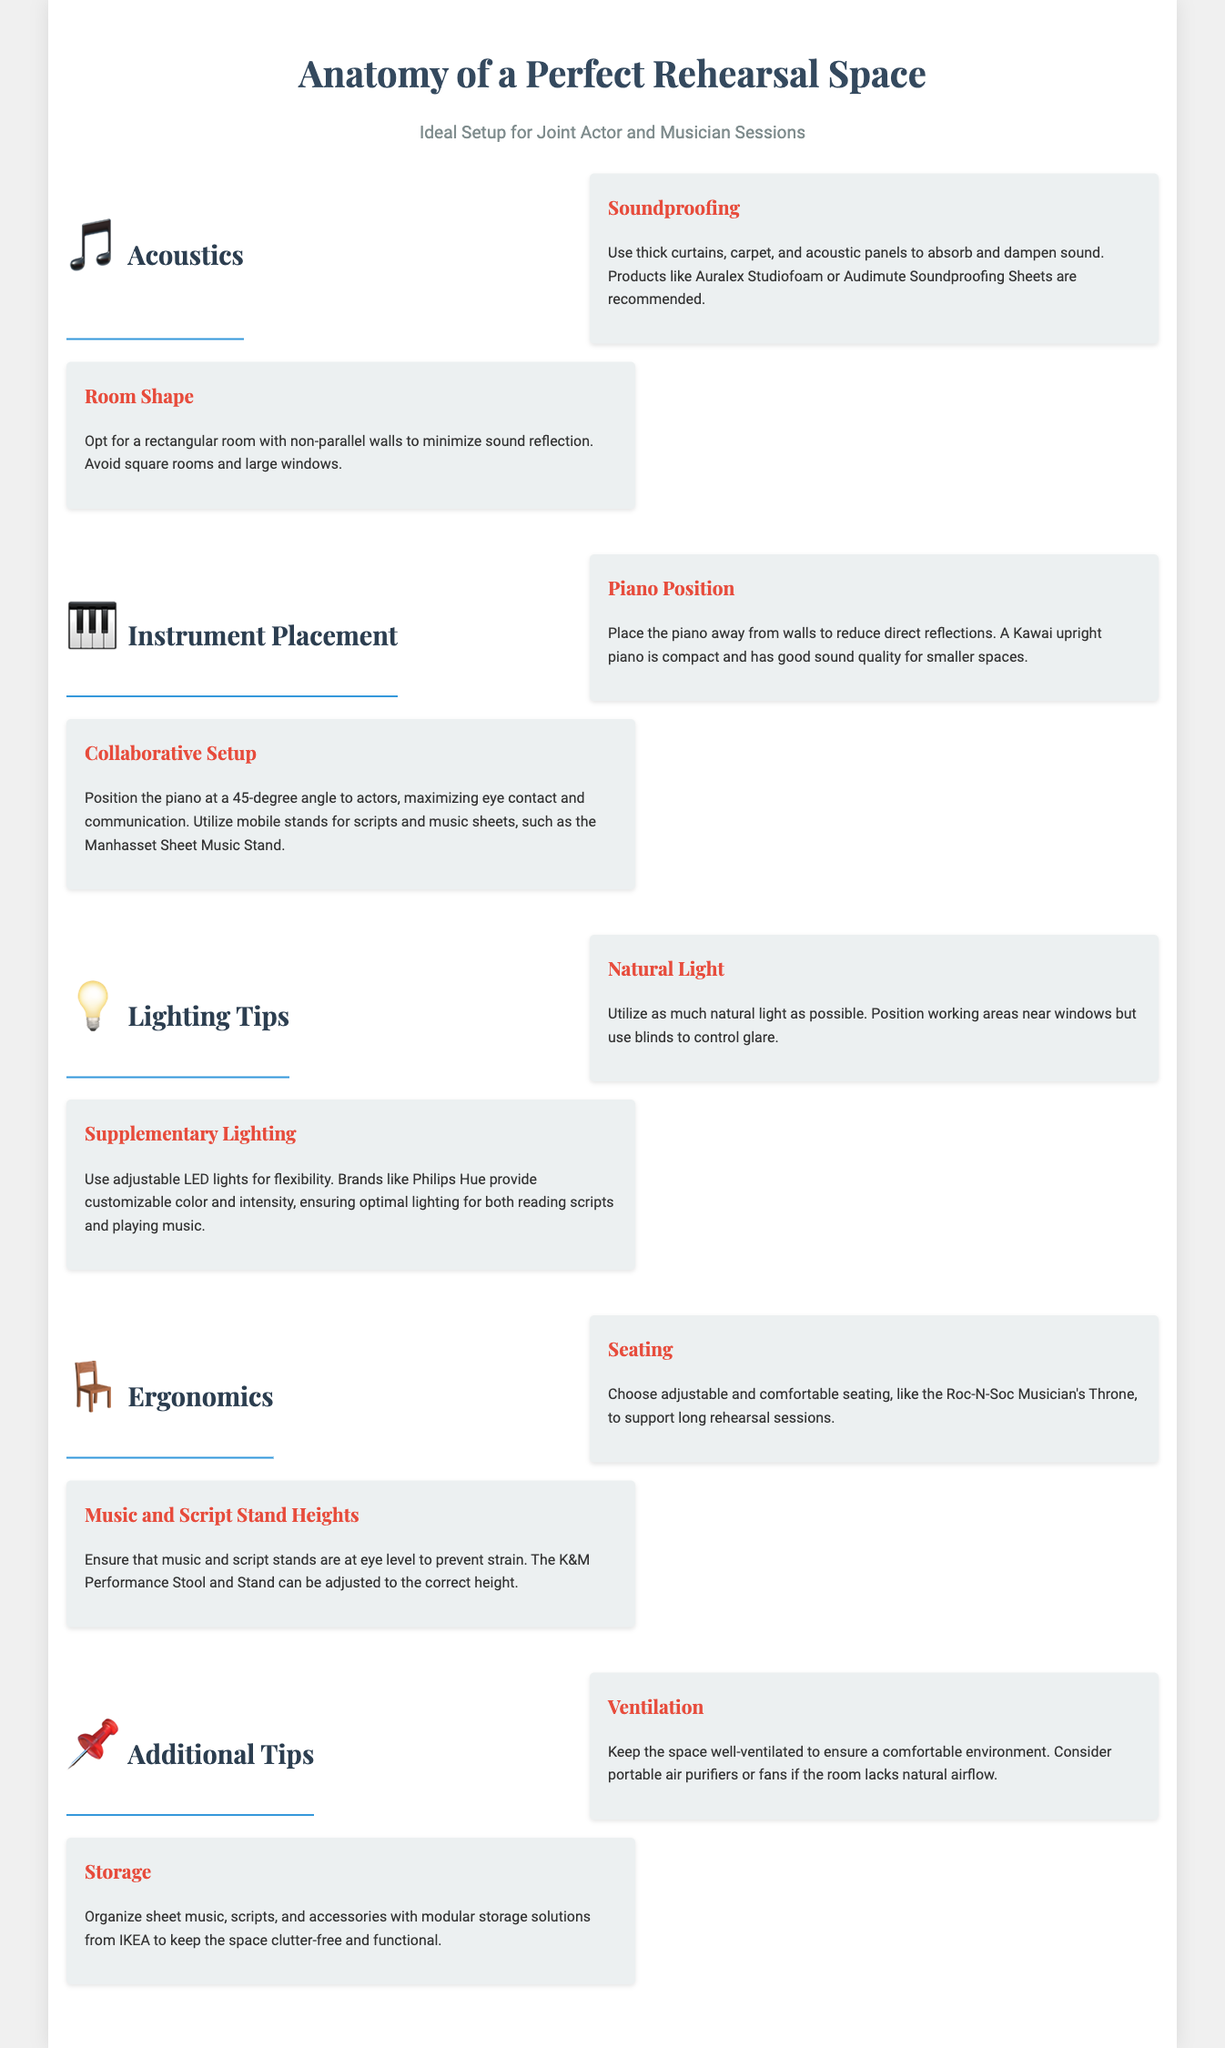what are recommended products for soundproofing? The document lists Auralex Studiofoam and Audimute Soundproofing Sheets as recommended products for soundproofing.
Answer: Auralex Studiofoam, Audimute Soundproofing Sheets what type of room shape is preferred? The document states that a rectangular room with non-parallel walls is preferred to minimize sound reflection.
Answer: Rectangular room with non-parallel walls why should the piano be positioned at a 45-degree angle? Positioning the piano at a 45-degree angle maximizes eye contact and communication with actors during rehearsals.
Answer: Maximize eye contact and communication what is a suggested seating option for musicians? The Roc-N-Soc Musician's Throne is suggested as a comfortable seating option for musicians.
Answer: Roc-N-Soc Musician's Throne how should music and script stands be adjusted? The document advises that music and script stands should be at eye level to prevent strain.
Answer: At eye level what is a tip for controlling glare from windows? The document suggests using blinds to control glare while utilizing natural light.
Answer: Use blinds 